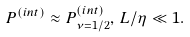Convert formula to latex. <formula><loc_0><loc_0><loc_500><loc_500>P ^ { ( i n t ) } \approx P _ { \nu = 1 / 2 } ^ { ( i n t ) } , \, L / \eta \ll 1 .</formula> 